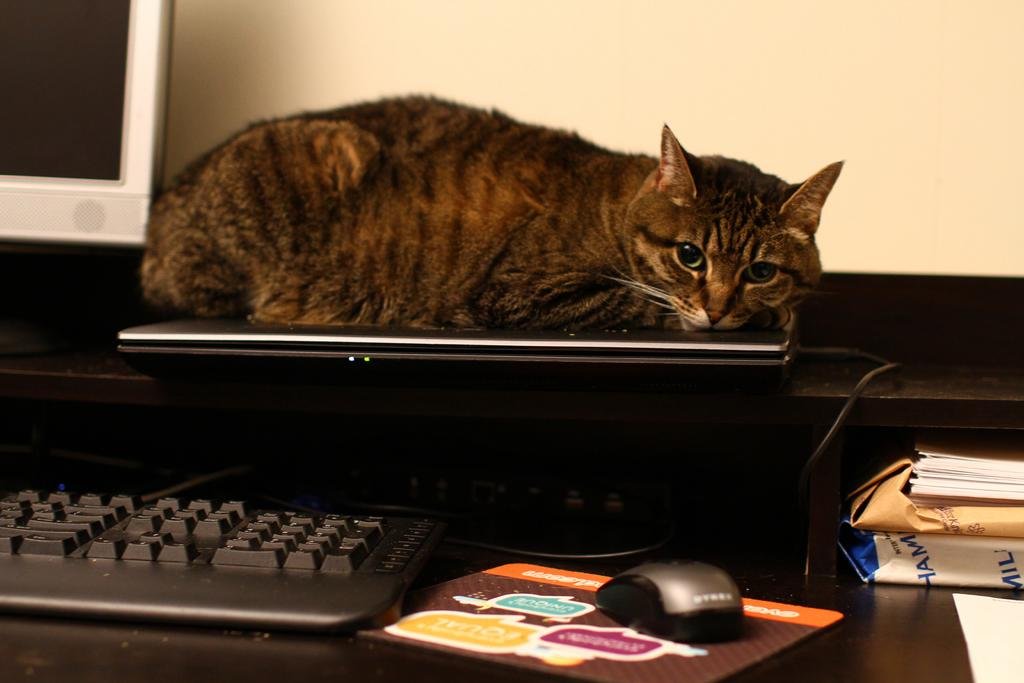What type of device is visible in the image? There is a keyboard and a monitor in the image. What other electronic device can be seen in the image? There is a laptop in the image. What is the cat doing in the image? The cat is near the laptop. What is used to control the cursor on the screen? There is a mouse in the image. What type of plant is growing on the mountain in the image? There is no plant or mountain present in the image. What tool is the person using to fix the wrench in the image? There is no wrench or tool usage depicted in the image. 